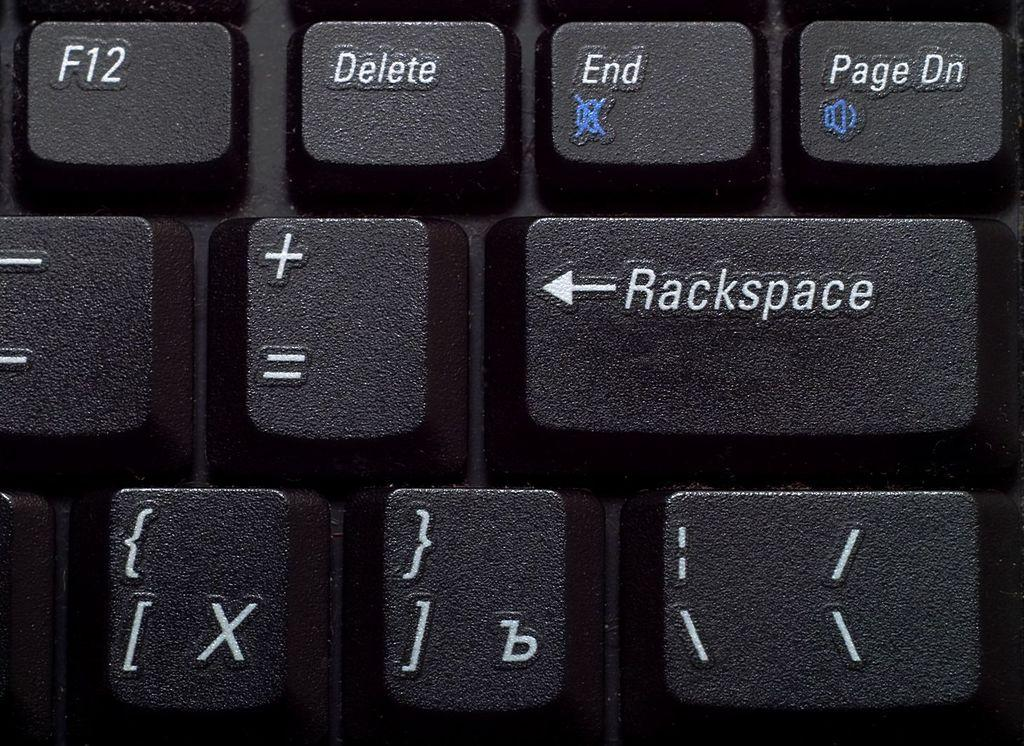<image>
Give a short and clear explanation of the subsequent image. A close of of a keyboard with rackspace where it should say backspace. 